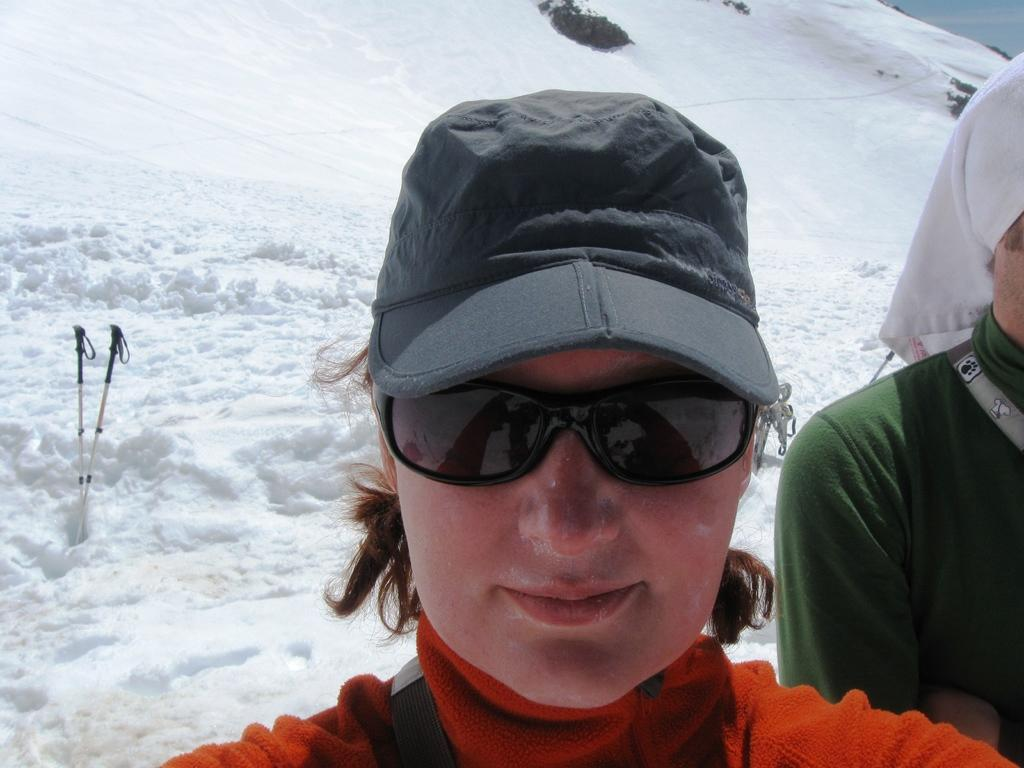Who is the main subject in the picture? There is a girl in the picture. What is the girl wearing that is noticeable? The girl is wearing black sunglasses. What is the girl doing in the image? The girl is looking into the camera. What is the ground covered with in the image? There is snow on the ground in the image. What equipment is visible in the image? There are two ski sticks in the image. What type of furniture can be seen in the image? There is no furniture present in the image. What branch of science is the girl studying in the image? The image does not provide any information about the girl's studies or interests. 